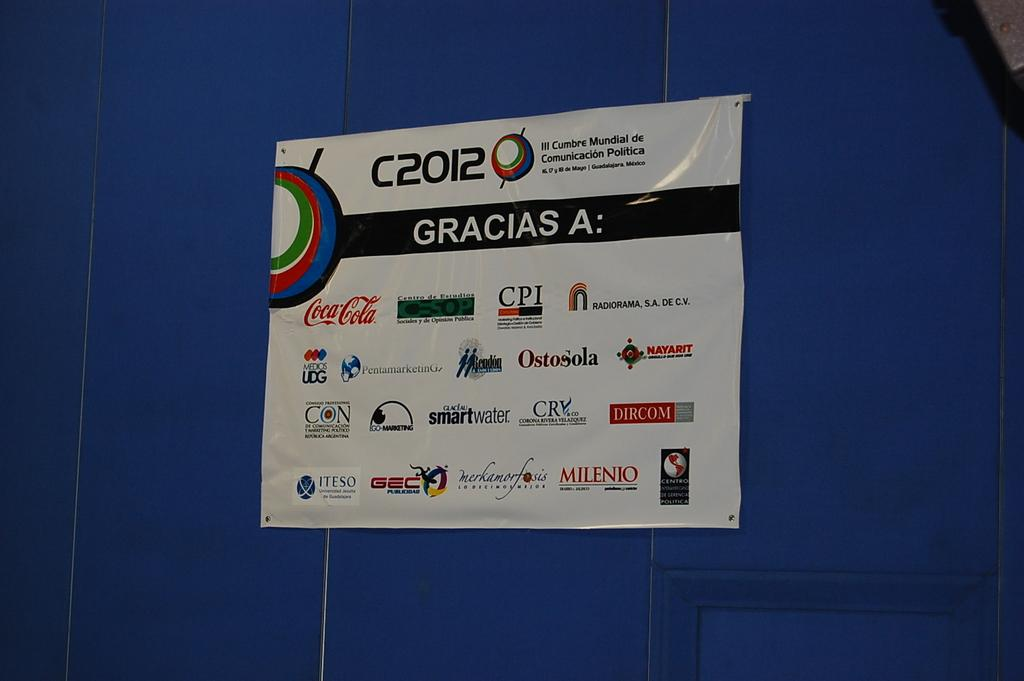<image>
Describe the image concisely. a sign outside that has the word gracias on it 